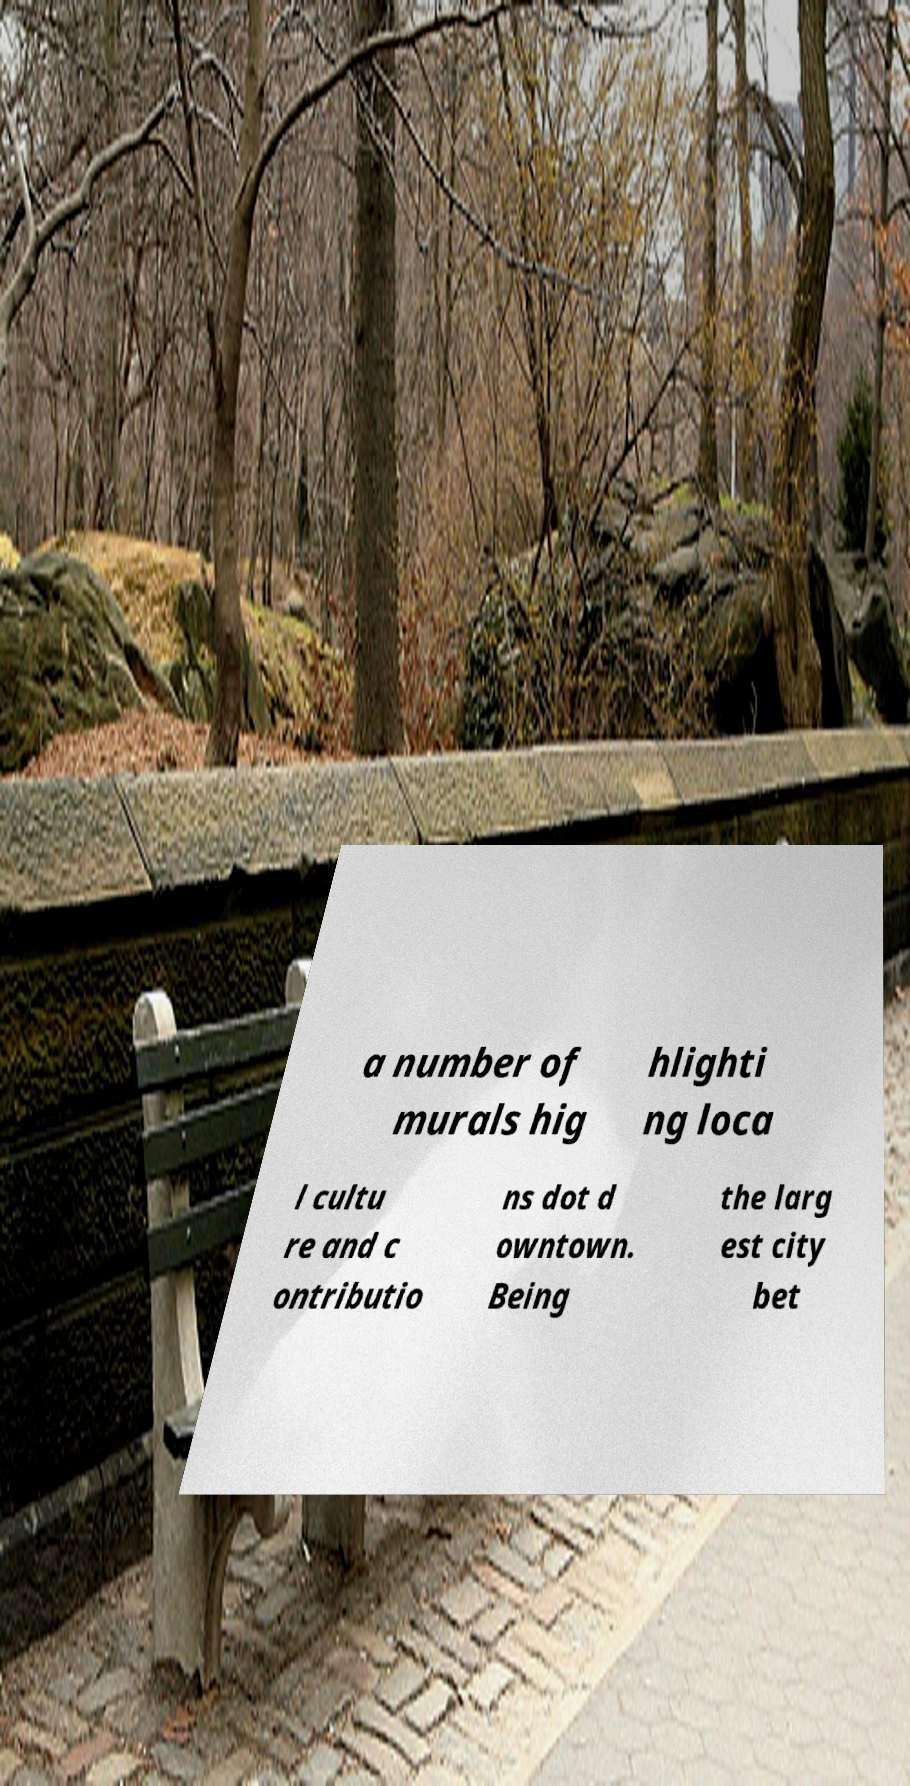Please read and relay the text visible in this image. What does it say? a number of murals hig hlighti ng loca l cultu re and c ontributio ns dot d owntown. Being the larg est city bet 